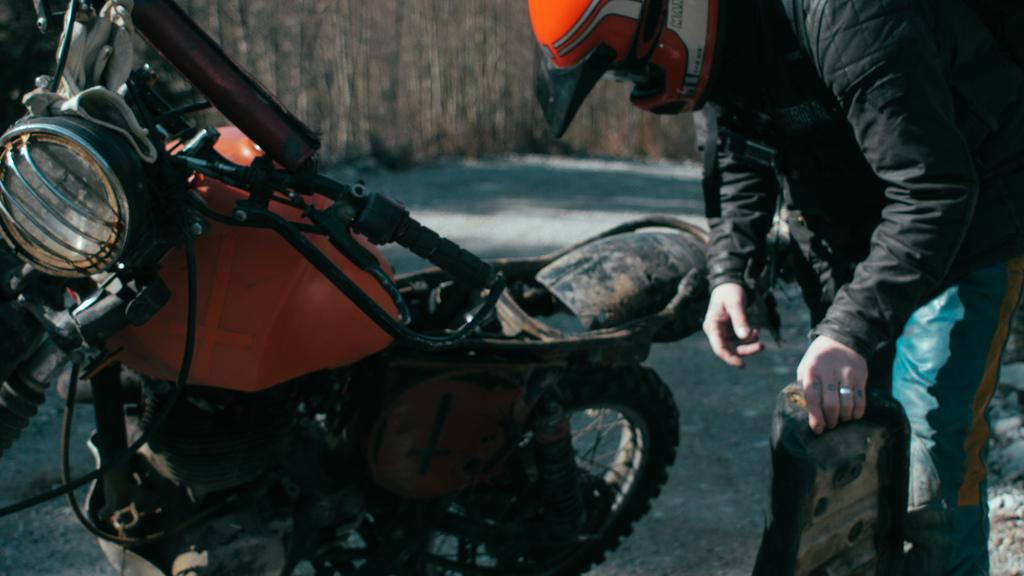What can be seen on the left side of the image? There is a bike on the left side of the image. What is happening on the right side of the image? There is a man on the right side of the image. What is the man wearing for safety? The man is wearing a helmet. What is the man holding in his hand? The man is holding something, but we cannot determine what it is from the image. What type of surface is visible at the bottom of the image? There is a road at the bottom of the image. What type of dress is the man wearing in the image? The man is not wearing a dress in the image; he is wearing a helmet and possibly other clothing, but we cannot determine the specifics from the image. 